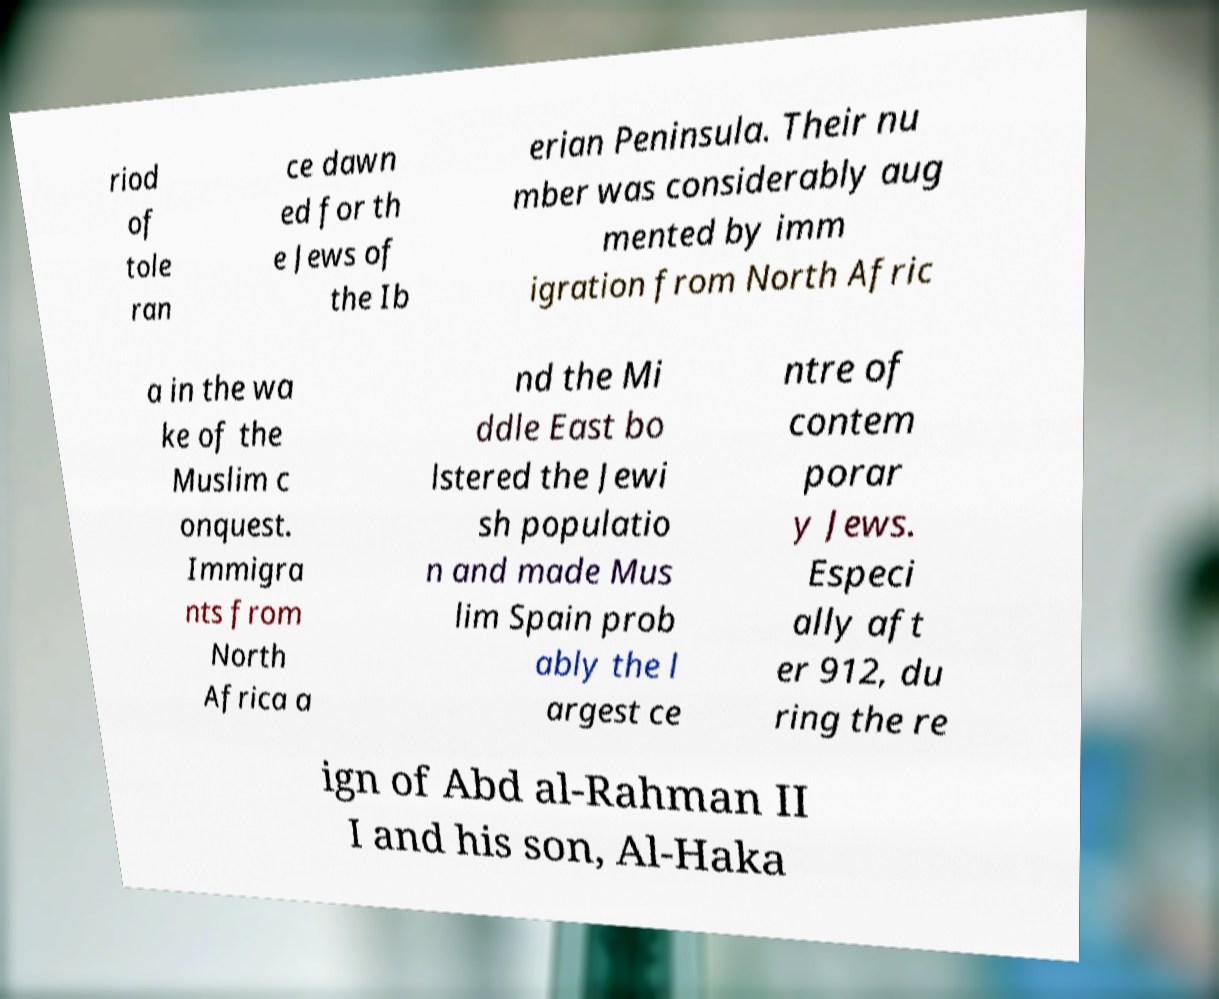For documentation purposes, I need the text within this image transcribed. Could you provide that? riod of tole ran ce dawn ed for th e Jews of the Ib erian Peninsula. Their nu mber was considerably aug mented by imm igration from North Afric a in the wa ke of the Muslim c onquest. Immigra nts from North Africa a nd the Mi ddle East bo lstered the Jewi sh populatio n and made Mus lim Spain prob ably the l argest ce ntre of contem porar y Jews. Especi ally aft er 912, du ring the re ign of Abd al-Rahman II I and his son, Al-Haka 